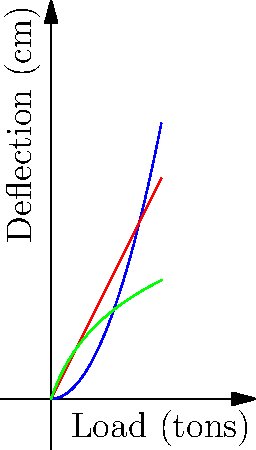As a policy think tank director, you're evaluating infrastructure proposals for a new bridge project. The graph shows the load-deflection characteristics of three bridge designs: truss, arch, and suspension. Which design would you recommend for a high-traffic urban area where minimizing deflection under heavy loads is crucial, and why? To answer this question, we need to analyze the load-deflection curves for each bridge type:

1. Truss Bridge (blue curve): $y = 0.5x^2$
   This shows a quadratic relationship, with deflection increasing rapidly as load increases.

2. Arch Bridge (red curve): $y = 2x$
   This shows a linear relationship, with deflection increasing steadily as load increases.

3. Suspension Bridge (green curve): $y = 3\log(x+1)$
   This shows a logarithmic relationship, with deflection increasing rapidly at first but then leveling off for higher loads.

For a high-traffic urban area with heavy loads:

1. We want minimal deflection under heavy loads.
2. The suspension bridge (green curve) shows the least deflection for higher loads.
3. While it deflects more than the others for very light loads, it performs significantly better as the load increases.
4. This design would provide the most stable and safe option for heavy urban traffic.

Additionally, suspension bridges typically have longer spans, which can be advantageous in urban settings where minimizing the number of support structures is often desirable.
Answer: Suspension bridge, due to minimal deflection under heavy loads. 